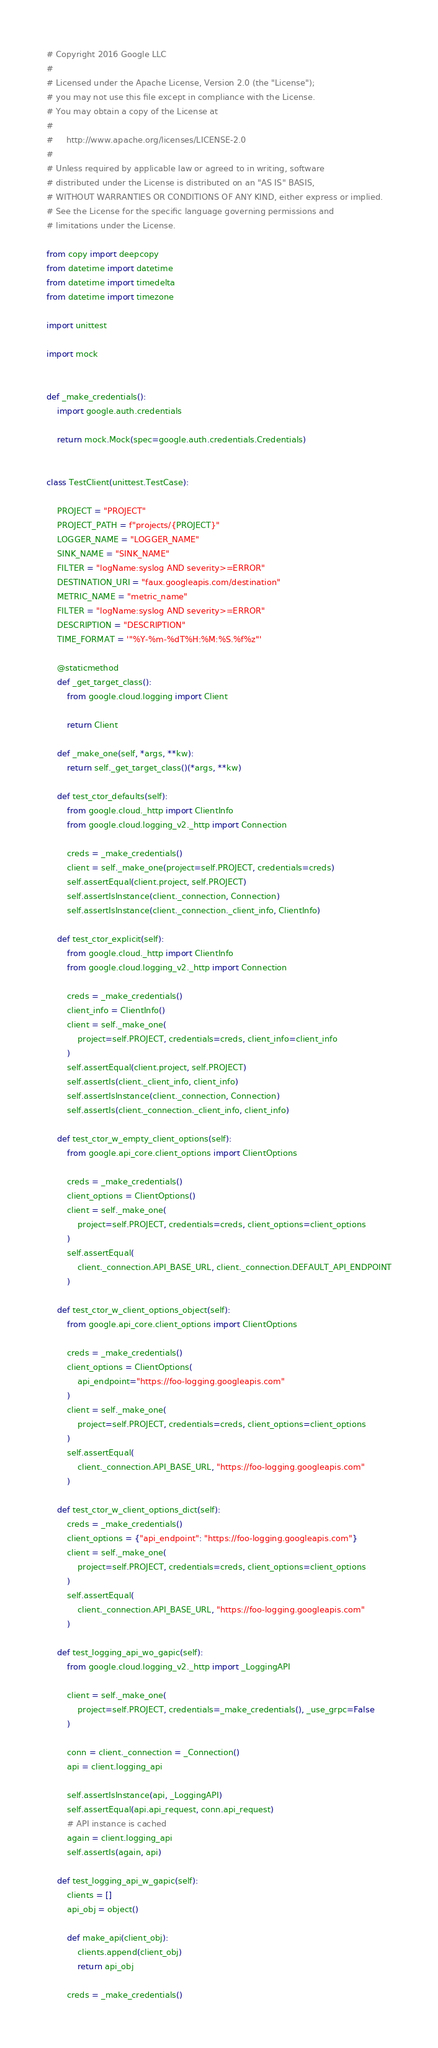Convert code to text. <code><loc_0><loc_0><loc_500><loc_500><_Python_># Copyright 2016 Google LLC
#
# Licensed under the Apache License, Version 2.0 (the "License");
# you may not use this file except in compliance with the License.
# You may obtain a copy of the License at
#
#     http://www.apache.org/licenses/LICENSE-2.0
#
# Unless required by applicable law or agreed to in writing, software
# distributed under the License is distributed on an "AS IS" BASIS,
# WITHOUT WARRANTIES OR CONDITIONS OF ANY KIND, either express or implied.
# See the License for the specific language governing permissions and
# limitations under the License.

from copy import deepcopy
from datetime import datetime
from datetime import timedelta
from datetime import timezone

import unittest

import mock


def _make_credentials():
    import google.auth.credentials

    return mock.Mock(spec=google.auth.credentials.Credentials)


class TestClient(unittest.TestCase):

    PROJECT = "PROJECT"
    PROJECT_PATH = f"projects/{PROJECT}"
    LOGGER_NAME = "LOGGER_NAME"
    SINK_NAME = "SINK_NAME"
    FILTER = "logName:syslog AND severity>=ERROR"
    DESTINATION_URI = "faux.googleapis.com/destination"
    METRIC_NAME = "metric_name"
    FILTER = "logName:syslog AND severity>=ERROR"
    DESCRIPTION = "DESCRIPTION"
    TIME_FORMAT = '"%Y-%m-%dT%H:%M:%S.%f%z"'

    @staticmethod
    def _get_target_class():
        from google.cloud.logging import Client

        return Client

    def _make_one(self, *args, **kw):
        return self._get_target_class()(*args, **kw)

    def test_ctor_defaults(self):
        from google.cloud._http import ClientInfo
        from google.cloud.logging_v2._http import Connection

        creds = _make_credentials()
        client = self._make_one(project=self.PROJECT, credentials=creds)
        self.assertEqual(client.project, self.PROJECT)
        self.assertIsInstance(client._connection, Connection)
        self.assertIsInstance(client._connection._client_info, ClientInfo)

    def test_ctor_explicit(self):
        from google.cloud._http import ClientInfo
        from google.cloud.logging_v2._http import Connection

        creds = _make_credentials()
        client_info = ClientInfo()
        client = self._make_one(
            project=self.PROJECT, credentials=creds, client_info=client_info
        )
        self.assertEqual(client.project, self.PROJECT)
        self.assertIs(client._client_info, client_info)
        self.assertIsInstance(client._connection, Connection)
        self.assertIs(client._connection._client_info, client_info)

    def test_ctor_w_empty_client_options(self):
        from google.api_core.client_options import ClientOptions

        creds = _make_credentials()
        client_options = ClientOptions()
        client = self._make_one(
            project=self.PROJECT, credentials=creds, client_options=client_options
        )
        self.assertEqual(
            client._connection.API_BASE_URL, client._connection.DEFAULT_API_ENDPOINT
        )

    def test_ctor_w_client_options_object(self):
        from google.api_core.client_options import ClientOptions

        creds = _make_credentials()
        client_options = ClientOptions(
            api_endpoint="https://foo-logging.googleapis.com"
        )
        client = self._make_one(
            project=self.PROJECT, credentials=creds, client_options=client_options
        )
        self.assertEqual(
            client._connection.API_BASE_URL, "https://foo-logging.googleapis.com"
        )

    def test_ctor_w_client_options_dict(self):
        creds = _make_credentials()
        client_options = {"api_endpoint": "https://foo-logging.googleapis.com"}
        client = self._make_one(
            project=self.PROJECT, credentials=creds, client_options=client_options
        )
        self.assertEqual(
            client._connection.API_BASE_URL, "https://foo-logging.googleapis.com"
        )

    def test_logging_api_wo_gapic(self):
        from google.cloud.logging_v2._http import _LoggingAPI

        client = self._make_one(
            project=self.PROJECT, credentials=_make_credentials(), _use_grpc=False
        )

        conn = client._connection = _Connection()
        api = client.logging_api

        self.assertIsInstance(api, _LoggingAPI)
        self.assertEqual(api.api_request, conn.api_request)
        # API instance is cached
        again = client.logging_api
        self.assertIs(again, api)

    def test_logging_api_w_gapic(self):
        clients = []
        api_obj = object()

        def make_api(client_obj):
            clients.append(client_obj)
            return api_obj

        creds = _make_credentials()</code> 